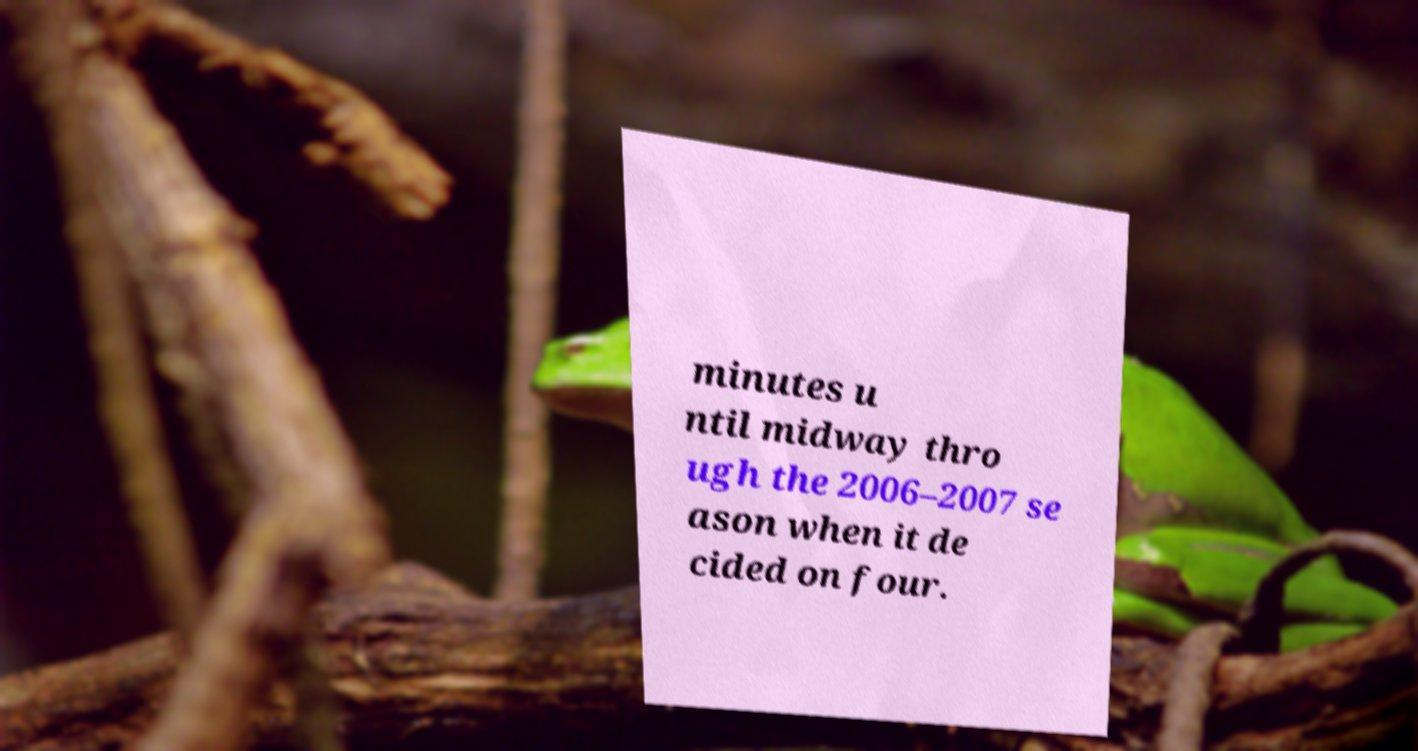Please identify and transcribe the text found in this image. minutes u ntil midway thro ugh the 2006–2007 se ason when it de cided on four. 